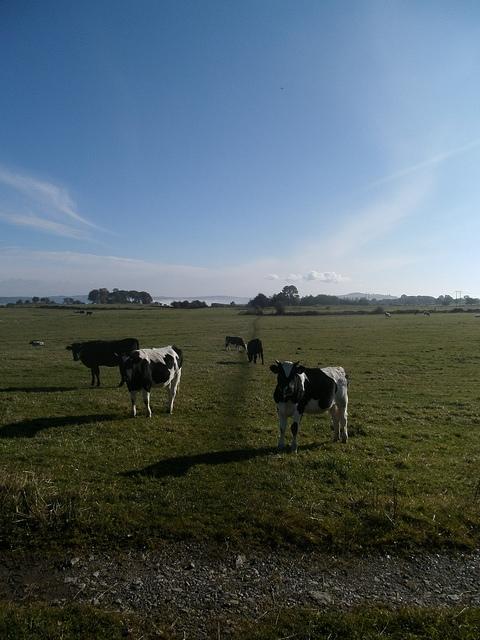What landscape is behind the cows?
Write a very short answer. Field. Which animals are these?
Write a very short answer. Cows. What type of fabric is made from the coats of these animals?
Short answer required. Leather. Which type of animal is on the field?
Be succinct. Cow. Which cow is darker in color?
Answer briefly. Left. Is it a cloudy day or clear day?
Concise answer only. Clear. What kind of animals are shown?
Be succinct. Cows. What is the cow doing?
Give a very brief answer. Standing. Is it going to rain?
Quick response, please. No. Is this landscape flat?
Quick response, please. Yes. Is that smoke in the sky?
Answer briefly. No. Does this cow have an ear tag?
Give a very brief answer. No. Are these cows resting?
Give a very brief answer. No. Are the animals in an enclosure?
Concise answer only. No. How many cows are there?
Keep it brief. 6. How many of the cattle are not grazing?
Concise answer only. 3. How many brown cows are in the image?
Quick response, please. 3. 